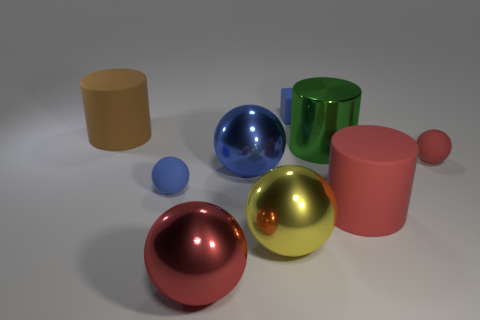Are there fewer big green metal cylinders that are to the left of the red metallic ball than large spheres?
Provide a short and direct response. Yes. Does the green metal object have the same shape as the large yellow thing?
Give a very brief answer. No. Are there any other things that are the same shape as the large red shiny thing?
Provide a succinct answer. Yes. Are there any red objects?
Provide a short and direct response. Yes. Is the shape of the small red object the same as the tiny blue rubber object that is behind the brown cylinder?
Give a very brief answer. No. There is a tiny blue thing in front of the big rubber object behind the large green thing; what is its material?
Keep it short and to the point. Rubber. What color is the block?
Offer a very short reply. Blue. Is the color of the ball in front of the big yellow thing the same as the big matte object to the left of the green metal thing?
Provide a short and direct response. No. The red object that is the same shape as the large brown matte object is what size?
Make the answer very short. Large. Is there a large ball that has the same color as the shiny cylinder?
Provide a short and direct response. No. 